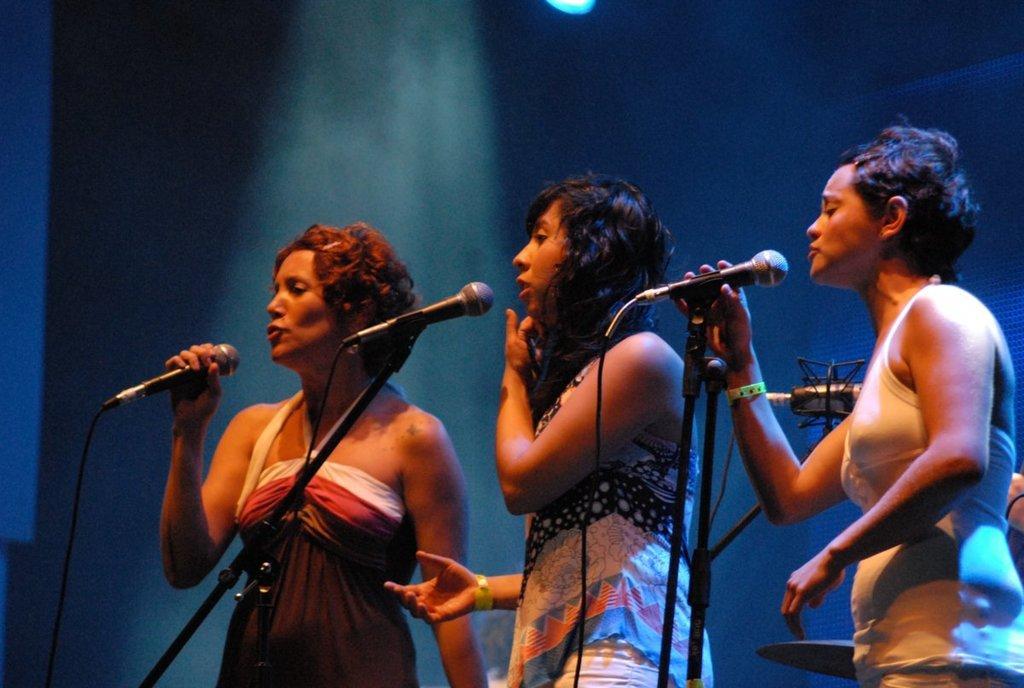Please provide a concise description of this image. In this image I see 3 women and there are mics in front of them. 